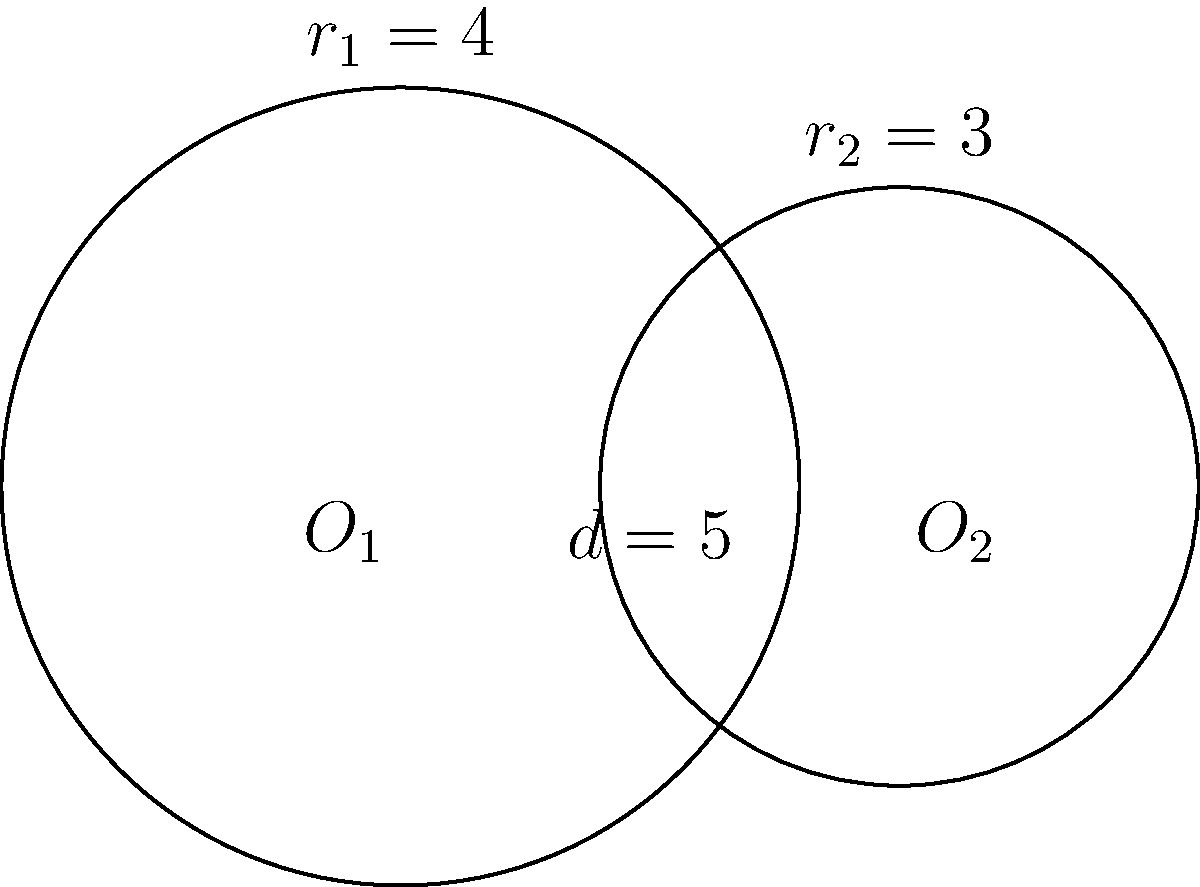In a data visualization project, you're analyzing the overlap of two datasets represented by circles. The circles have radii of 4 and 3 units, with their centers 5 units apart. Calculate the area of intersection between these two datasets, representing the shared data points. Round your answer to two decimal places. To find the area of intersection between two circles, we'll use the following steps:

1) First, we need to check if the circles intersect. The distance between centers (d) is 5, and the sum of radii is 7. Since d < (r1 + r2), the circles do intersect.

2) We'll use the formula for the area of intersection:

   $$A = r_1^2 \arccos(\frac{d^2 + r_1^2 - r_2^2}{2dr_1}) + r_2^2 \arccos(\frac{d^2 + r_2^2 - r_1^2}{2dr_2}) - \frac{1}{2}\sqrt{(-d+r_1+r_2)(d+r_1-r_2)(d-r_1+r_2)(d+r_1+r_2)}$$

3) Plugging in our values:
   $r_1 = 4$, $r_2 = 3$, $d = 5$

4) Calculate each part:
   
   $$4^2 \arccos(\frac{5^2 + 4^2 - 3^2}{2 \cdot 5 \cdot 4}) + 3^2 \arccos(\frac{5^2 + 3^2 - 4^2}{2 \cdot 5 \cdot 3}) - \frac{1}{2}\sqrt{(-5+4+3)(5+4-3)(5-4+3)(5+4+3)}$$

5) Simplify:
   
   $$16 \arccos(0.775) + 9 \arccos(0.7667) - \frac{1}{2}\sqrt{2 \cdot 6 \cdot 4 \cdot 12}$$

6) Calculate:
   
   $$16 \cdot 0.7003 + 9 \cdot 0.7297 - \frac{1}{2}\sqrt{576}$$
   
   $$11.2048 + 6.5673 - 12$$
   
   $$5.7721$$

7) Rounding to two decimal places: 5.77
Answer: 5.77 square units 